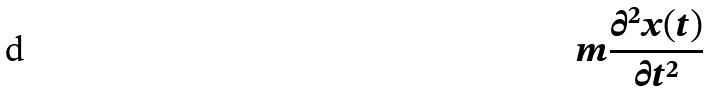Convert formula to latex. <formula><loc_0><loc_0><loc_500><loc_500>m \frac { \partial ^ { 2 } x ( t ) } { \partial t ^ { 2 } }</formula> 